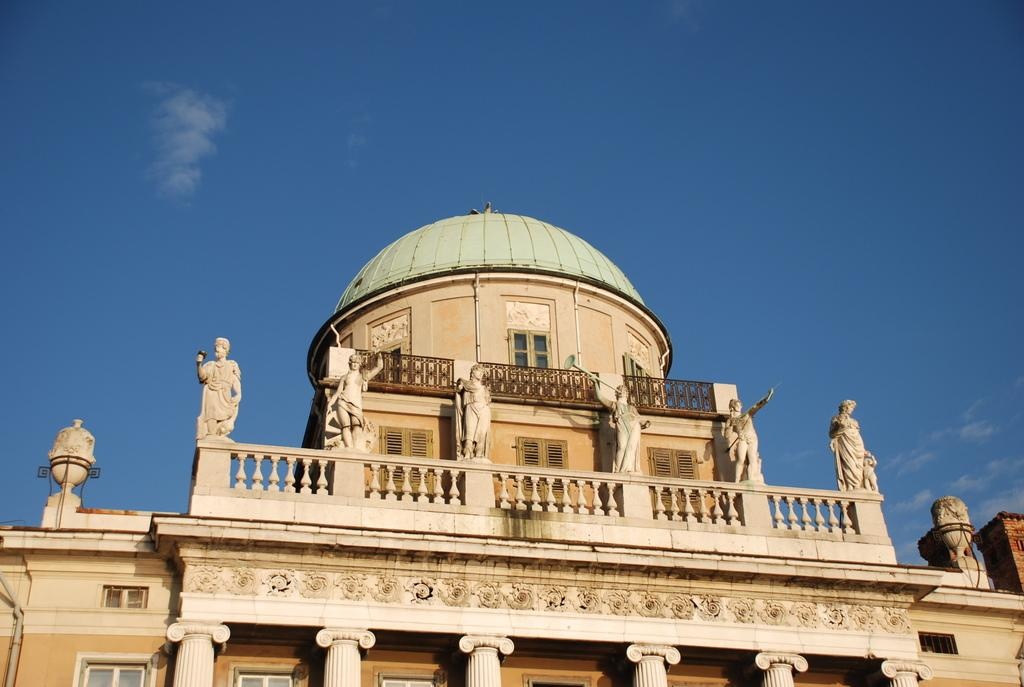What type of structure is present in the image? There is a building in the image. What feature can be seen on the building? The building has windows. What additional objects are present in the image? There are sculptures in the image. What can be seen in the background of the image? The sky is visible in the background of the image. What type of nail is being used by the creature in the image? There is no creature or nail present in the image. 